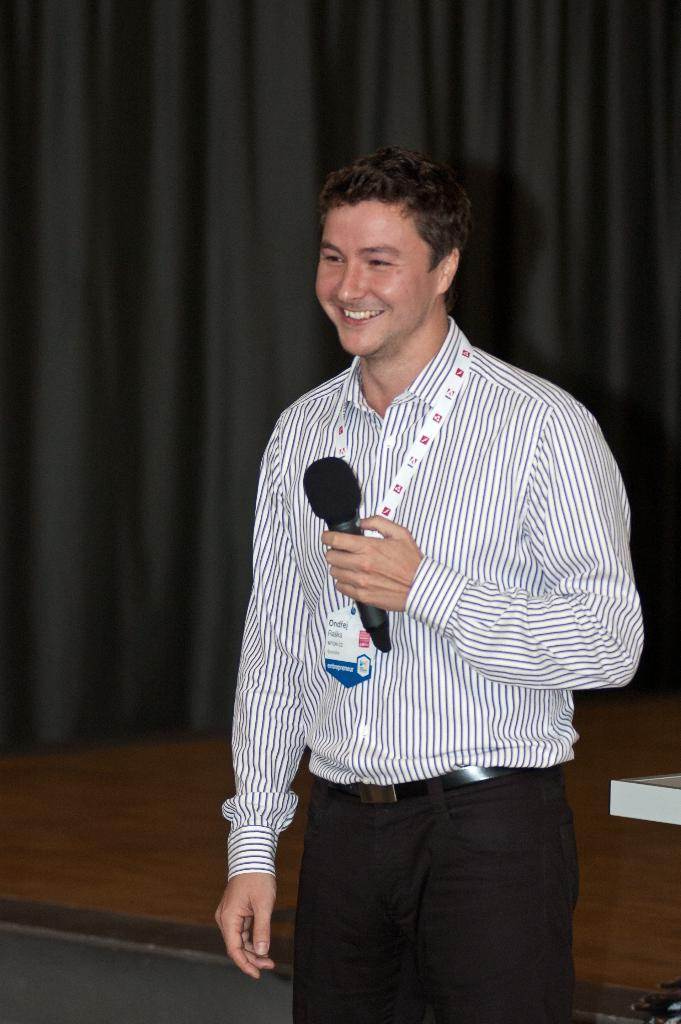Who is the main subject in the image? There is a man in the image. What is the man holding in the image? The man is holding a microphone. What element in the image indicates a stage might be present? The curtain visible in the image suggests a stage is present in the background. How many fish can be seen swimming near the man in the image? There are no fish visible in the image. What achievement has the man been recognized for in the image? The image does not provide information about any achievements the man might have been recognized for. 